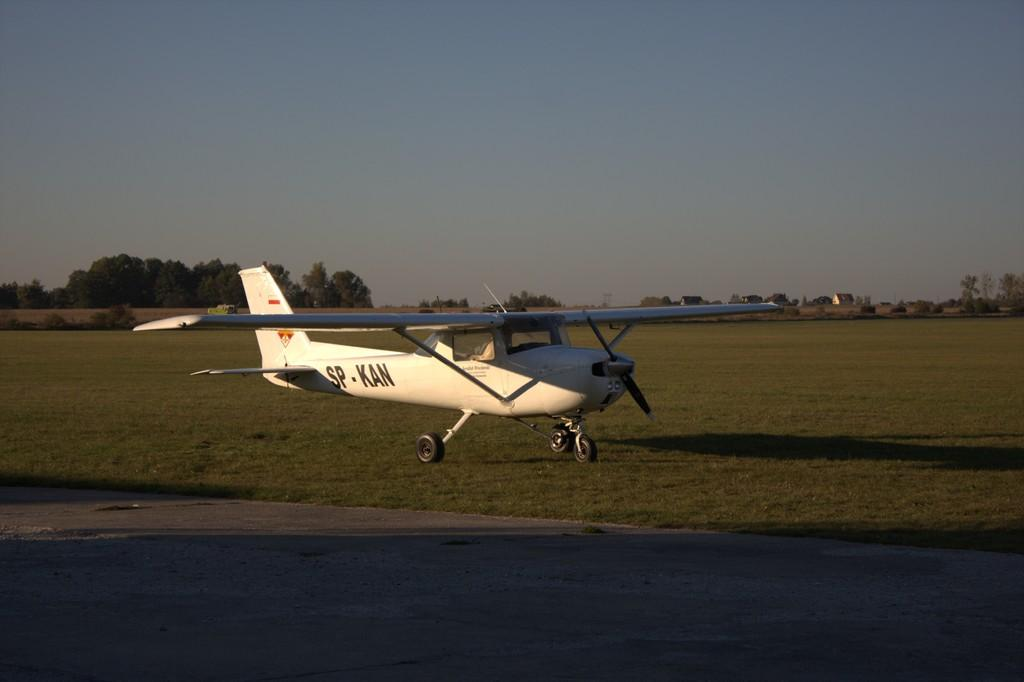<image>
Give a short and clear explanation of the subsequent image. a small propeller plane has letters SP-KAN on it 